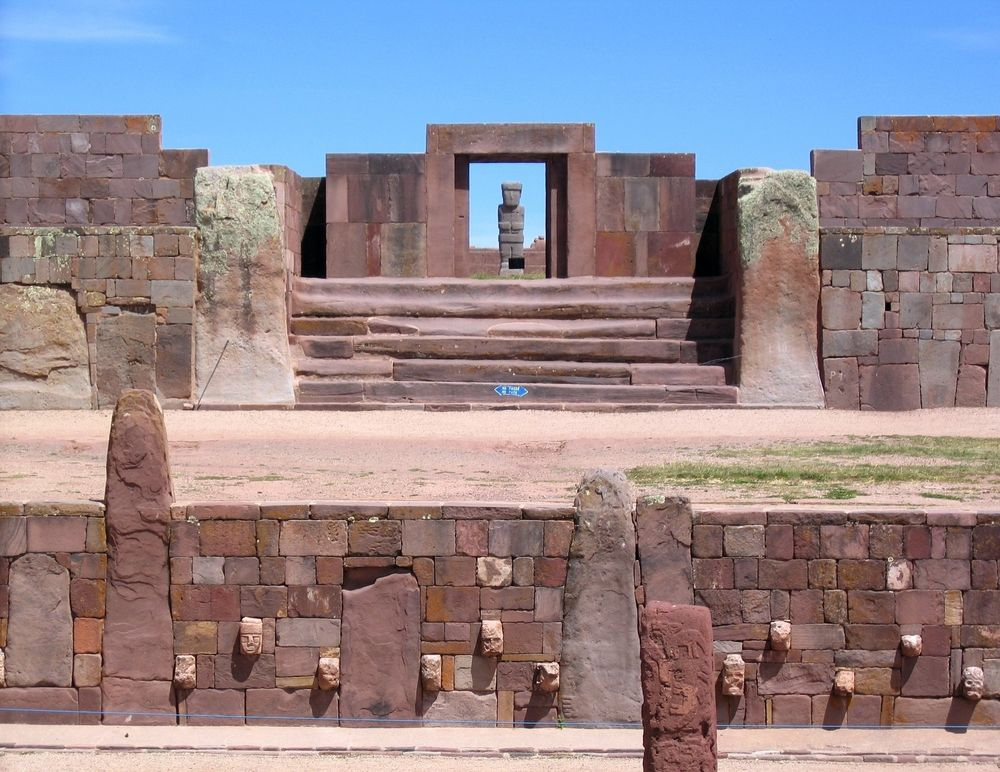Describe the atmosphere this place might have on a quiet, clear morning. On a quiet, clear morning, the Tiwanaku ruins exude an air of tranquil majesty. The crisp morning light softly illuminates the reddish-brown stones, casting gentle shadows that dance on the ancient walls. The serene atmosphere is punctuated only by the distant sounds of nature, enhancing the sense of timelessness. As the cool breeze sweeps through the ruins, one might feel a deep connection with the past, as if the spirits of the ancient Tiwanaku people still linger in the air, whispering stories of a bygone era. The stillness and clarity of the morning enhance the site's mystique, making it an evocative place of reflection and wonder. What historical significance do the Tiwanaku ruins hold? The Tiwanaku ruins are of profound historical significance, representing the remains of an ancient civilization that flourished in the Andean region of South America around 500 to 950 AD. They are considered a crucial cultural and spiritual center of the Tiwanaku Empire, which significantly influenced later Andean civilizations, including the Inca. The ruins, including temples, pyramids, and monolithic structures like the Gateway of the Sun, testify to the sophisticated engineering and architectural skills of the Tiwanaku people. This site provides invaluable insights into pre-Columbian history, indigenous culture, and the development of early urbanism in the Andes. Excavations and studies have revealed complex social, political, and religious facets of Tiwanaku society, making it a UNESCO World Heritage Site and a key destination for archaeologists and historians. Imagine an ancient Tiwanaku ceremony taking place here. Describe it in detail. Imagine an ancient Tiwanaku ceremony unfolding amidst these majestic ruins. The first light of dawn breaks over the horizon, casting a golden hue on the meticulously carved stones. The air is filled with the subtle fragrance of burning incense, a fragrant mix of local herbs and resins. Priests and priestesses, donned in elaborate ceremonial attire adorned with feathers, gold ornaments, and woven textiles, gracefully move towards the central staircase. The high priest, holding a ritualistic staff, ascends the stairs and stands at the doorway, his silhouette framed dramatically against the sky. He begins a ritual chant in the now-lost Tiwanaku language, his voice resonating with authority and reverence. Accompanied by the rhythmic beat of drums and the haunting melodies of bone flutes, offerings of crops, textiles, and carved figurines are placed before sacred statues. The community gathers below, their faces reflecting a mix of awe and devotion. As the ceremony reaches its climax, the high priest lifts a ceremonial chalice, made of ornately decorated gold, towards the heavens, offering a prayer of thanks and plea for blessings. The air is charged with spiritual energy, bridging the past and present, as the Tiwanaku people honor their deities and ancestors, bonding their community through shared tradition and reverence. 